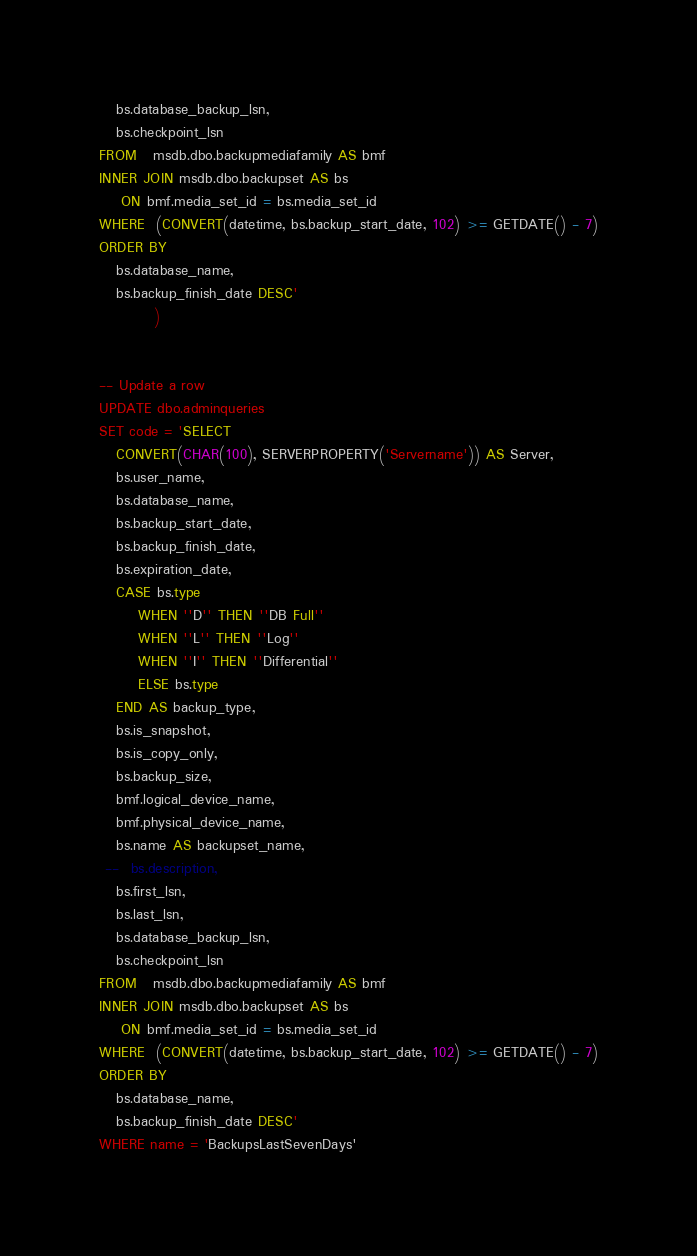<code> <loc_0><loc_0><loc_500><loc_500><_SQL_>   bs.database_backup_lsn,
   bs.checkpoint_lsn
FROM   msdb.dbo.backupmediafamily AS bmf
INNER JOIN msdb.dbo.backupset AS bs
    ON bmf.media_set_id = bs.media_set_id
WHERE  (CONVERT(datetime, bs.backup_start_date, 102) >= GETDATE() - 7)
ORDER BY 
   bs.database_name,
   bs.backup_finish_date DESC'
          )


-- Update a row
UPDATE dbo.adminqueries
SET code = 'SELECT 
   CONVERT(CHAR(100), SERVERPROPERTY('Servername')) AS Server,
   bs.user_name,
   bs.database_name,
   bs.backup_start_date, 
   bs.backup_finish_date,
   bs.expiration_date,
   CASE bs.type 
       WHEN ''D'' THEN ''DB Full''
       WHEN ''L'' THEN ''Log''
       WHEN ''I'' THEN ''Differential''
       ELSE bs.type
   END AS backup_type,
   bs.is_snapshot,
   bs.is_copy_only,
   bs.backup_size, 
   bmf.logical_device_name, 
   bmf.physical_device_name,  
   bs.name AS backupset_name,
 --  bs.description,
   bs.first_lsn,
   bs.last_lsn,
   bs.database_backup_lsn,
   bs.checkpoint_lsn
FROM   msdb.dbo.backupmediafamily AS bmf
INNER JOIN msdb.dbo.backupset AS bs
    ON bmf.media_set_id = bs.media_set_id
WHERE  (CONVERT(datetime, bs.backup_start_date, 102) >= GETDATE() - 7)
ORDER BY 
   bs.database_name,
   bs.backup_finish_date DESC'
WHERE name = 'BackupsLastSevenDays'



</code> 